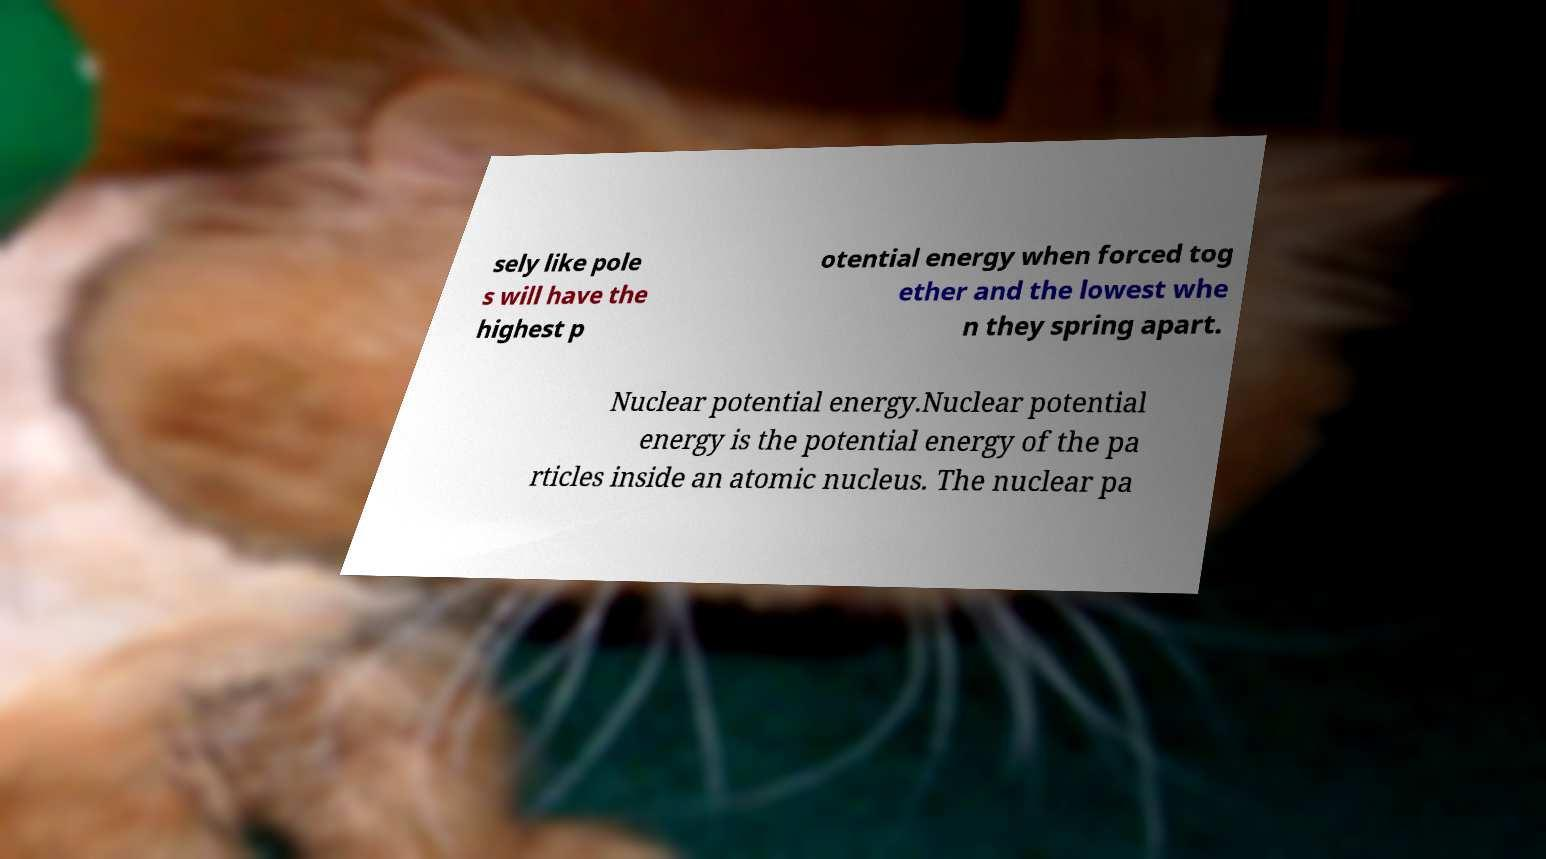Please identify and transcribe the text found in this image. sely like pole s will have the highest p otential energy when forced tog ether and the lowest whe n they spring apart. Nuclear potential energy.Nuclear potential energy is the potential energy of the pa rticles inside an atomic nucleus. The nuclear pa 